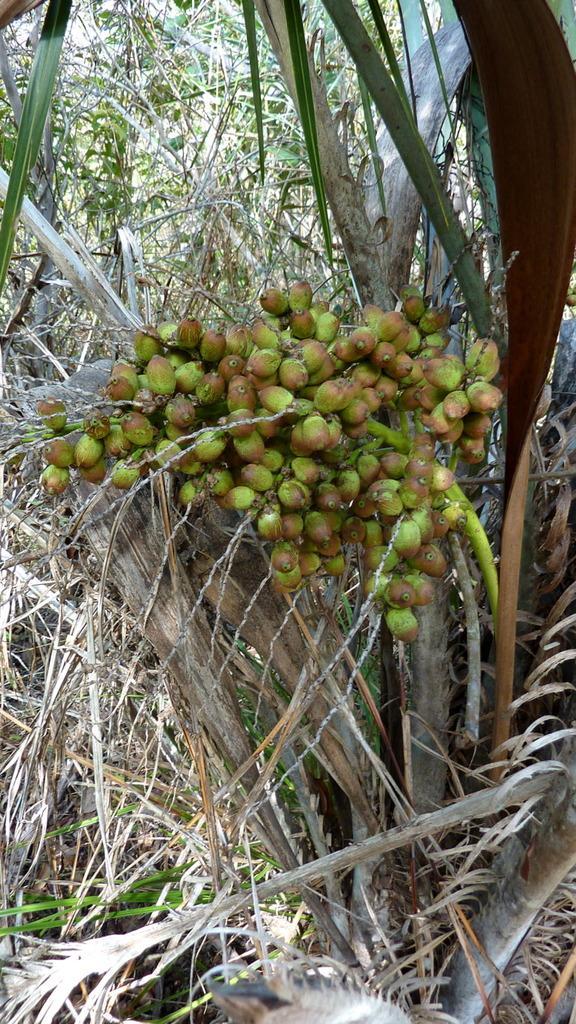Please provide a concise description of this image. In the image we can see the fry fruit tree. 